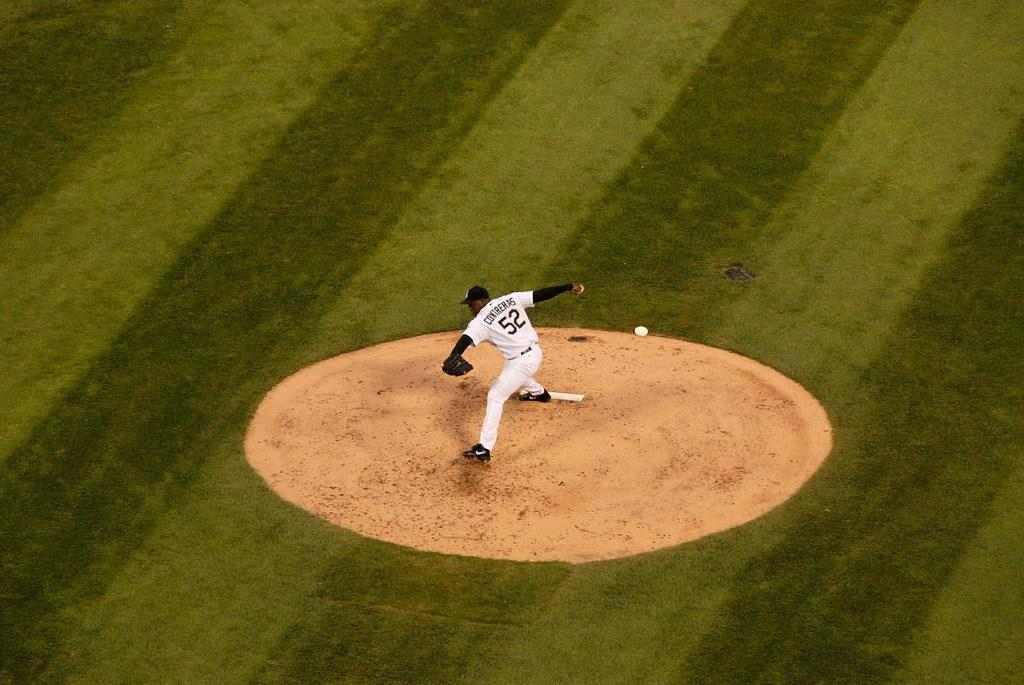<image>
Share a concise interpretation of the image provided. Contreras wears number 52 and is about to pitch the baseball. 